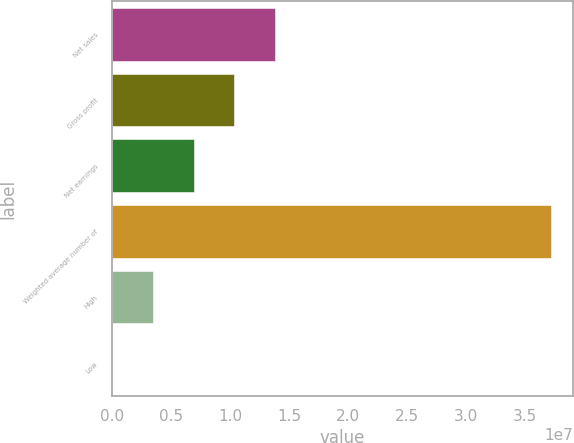Convert chart to OTSL. <chart><loc_0><loc_0><loc_500><loc_500><bar_chart><fcel>Net sales<fcel>Gross profit<fcel>Net earnings<fcel>Weighted average number of<fcel>High<fcel>Low<nl><fcel>1.37655e+07<fcel>1.03241e+07<fcel>6.88279e+06<fcel>3.71703e+07<fcel>3.44143e+06<fcel>75.33<nl></chart> 